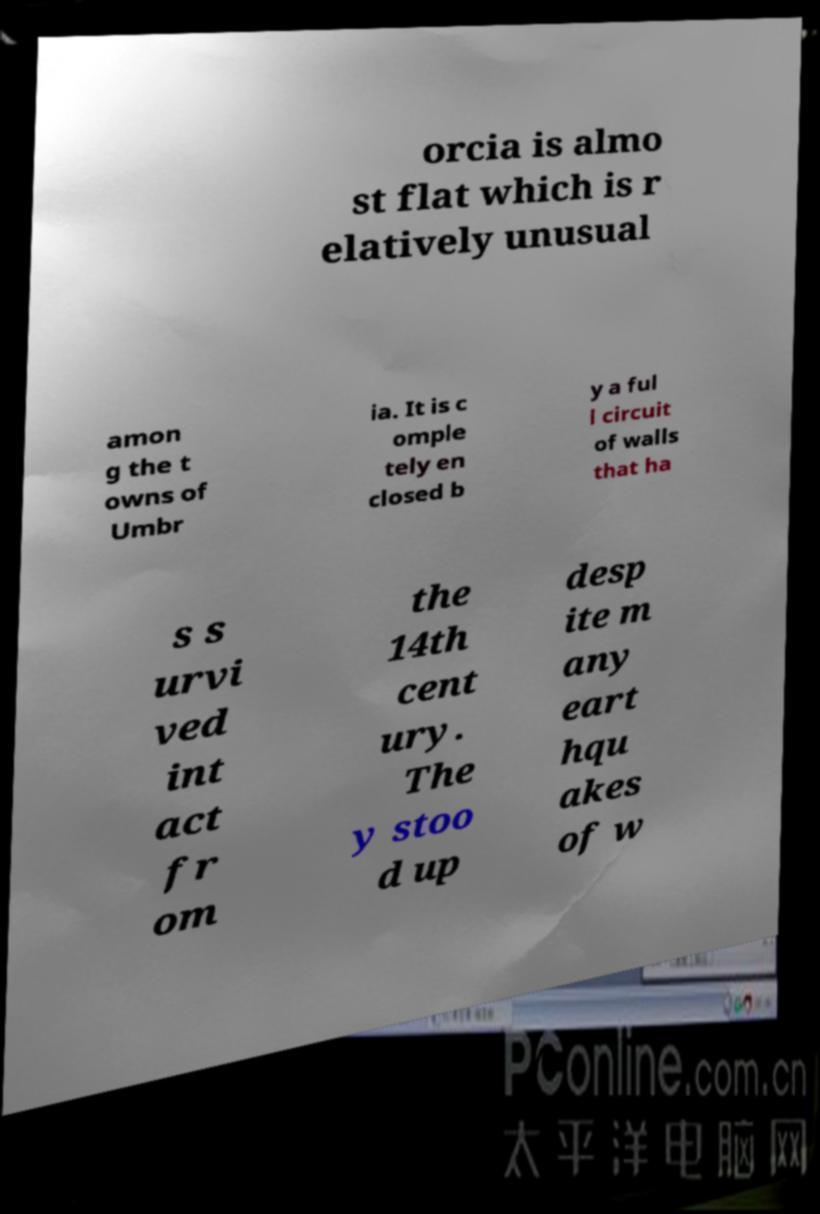What messages or text are displayed in this image? I need them in a readable, typed format. orcia is almo st flat which is r elatively unusual amon g the t owns of Umbr ia. It is c omple tely en closed b y a ful l circuit of walls that ha s s urvi ved int act fr om the 14th cent ury. The y stoo d up desp ite m any eart hqu akes of w 